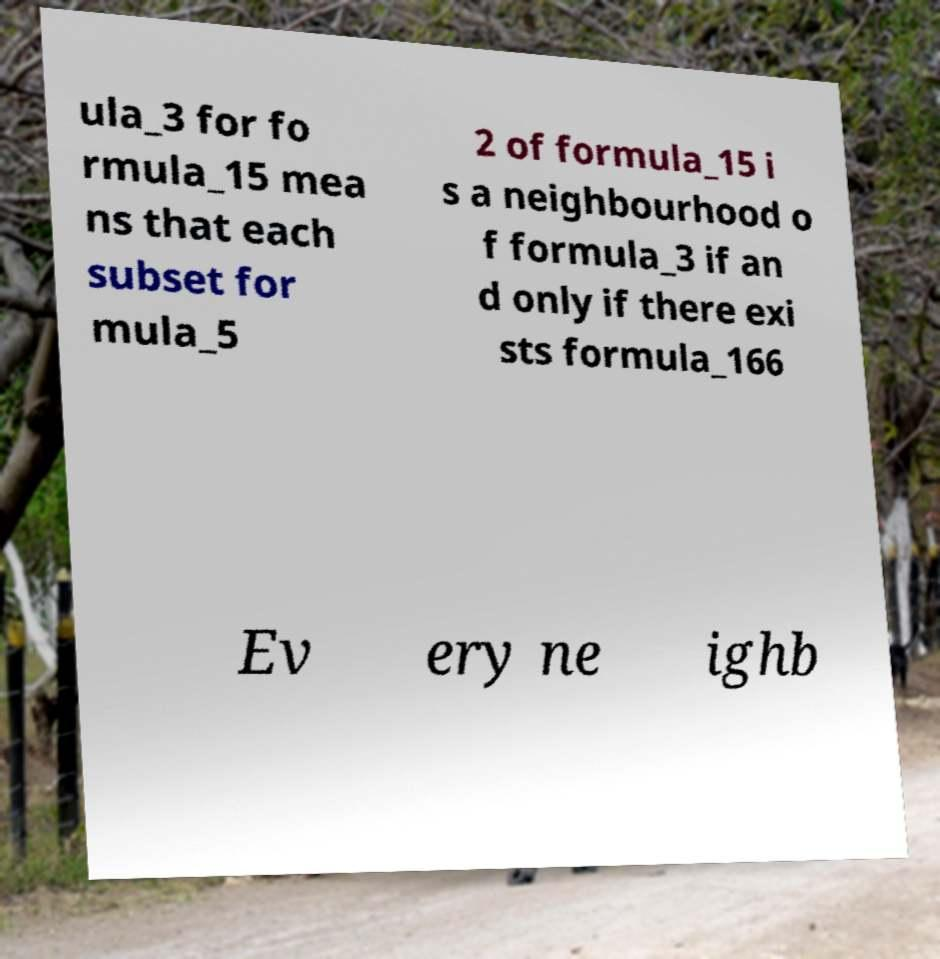Please identify and transcribe the text found in this image. ula_3 for fo rmula_15 mea ns that each subset for mula_5 2 of formula_15 i s a neighbourhood o f formula_3 if an d only if there exi sts formula_166 Ev ery ne ighb 